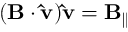<formula> <loc_0><loc_0><loc_500><loc_500>( B \cdot \hat { v } ) \hat { v } = B _ { \| }</formula> 